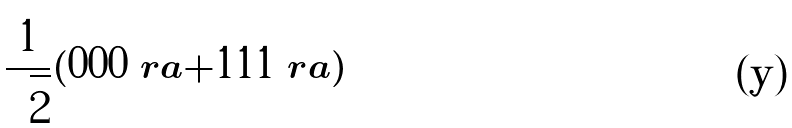Convert formula to latex. <formula><loc_0><loc_0><loc_500><loc_500>\frac { 1 } { \sqrt { 2 } } ( | 0 0 0 \ r a + | 1 1 1 \ r a )</formula> 